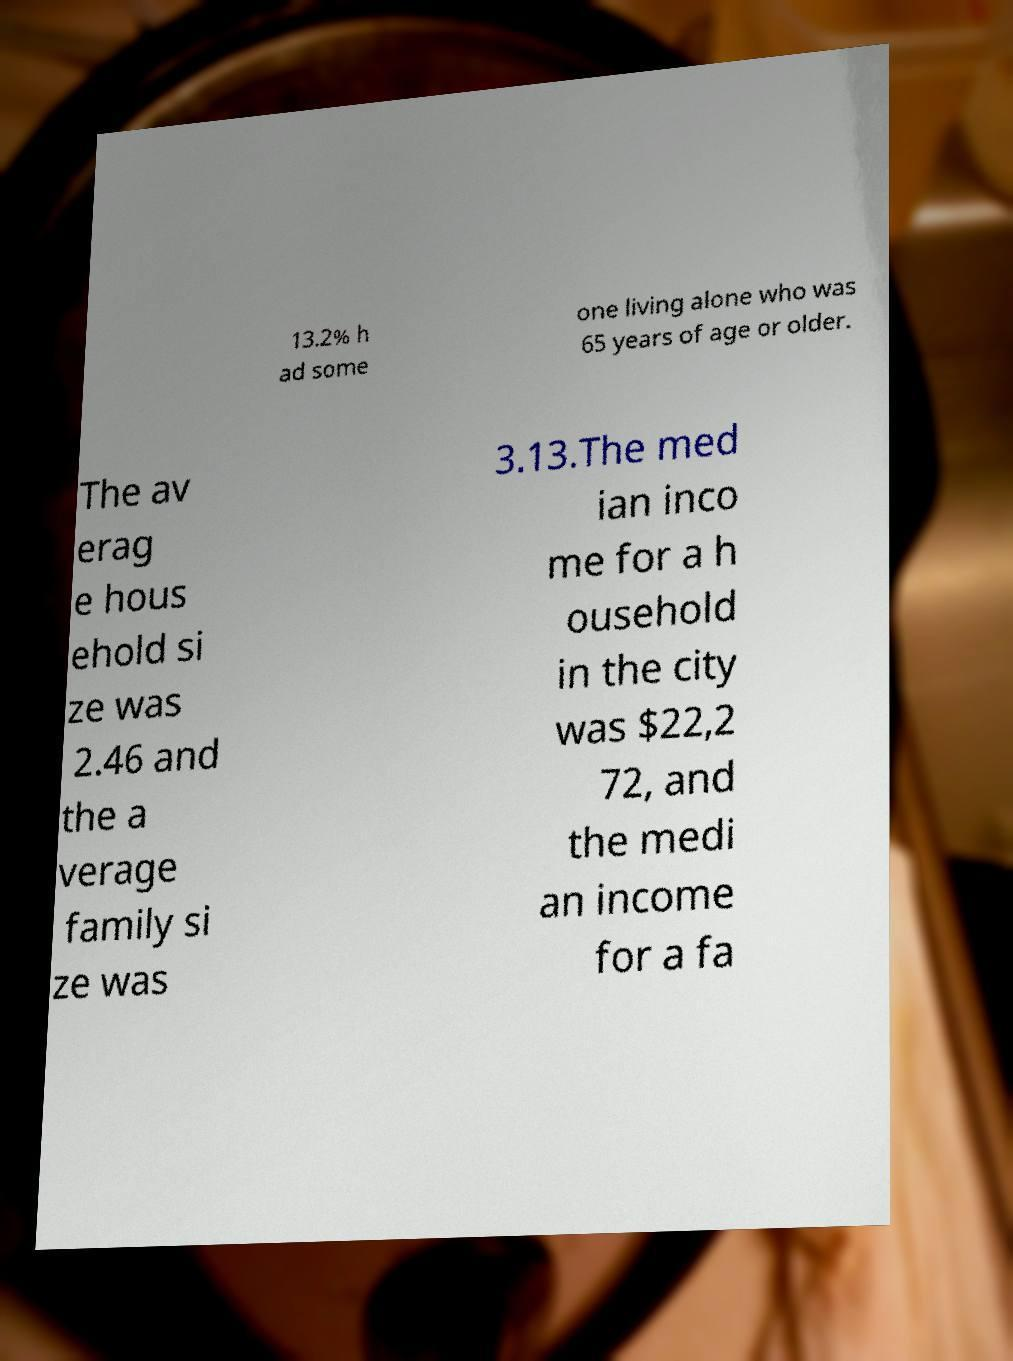Could you assist in decoding the text presented in this image and type it out clearly? 13.2% h ad some one living alone who was 65 years of age or older. The av erag e hous ehold si ze was 2.46 and the a verage family si ze was 3.13.The med ian inco me for a h ousehold in the city was $22,2 72, and the medi an income for a fa 